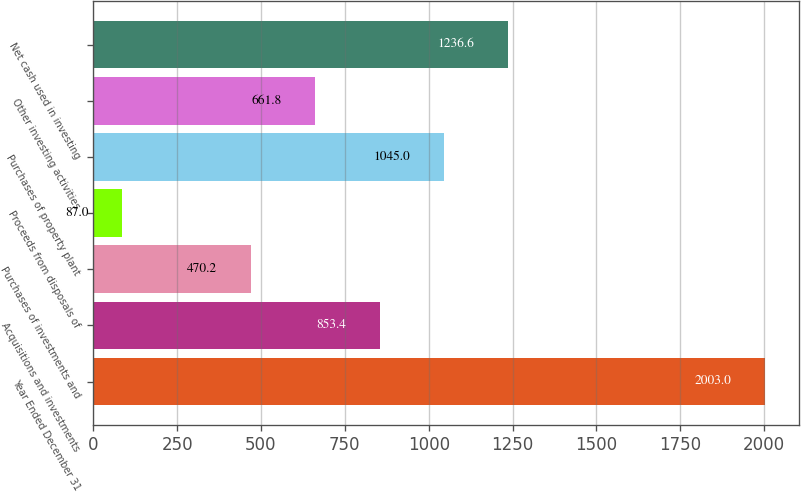Convert chart. <chart><loc_0><loc_0><loc_500><loc_500><bar_chart><fcel>Year Ended December 31<fcel>Acquisitions and investments<fcel>Purchases of investments and<fcel>Proceeds from disposals of<fcel>Purchases of property plant<fcel>Other investing activities<fcel>Net cash used in investing<nl><fcel>2003<fcel>853.4<fcel>470.2<fcel>87<fcel>1045<fcel>661.8<fcel>1236.6<nl></chart> 